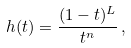Convert formula to latex. <formula><loc_0><loc_0><loc_500><loc_500>h ( t ) = \frac { ( 1 - t ) ^ { L } } { t ^ { n } } \, ,</formula> 